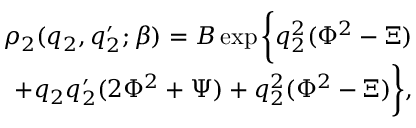Convert formula to latex. <formula><loc_0><loc_0><loc_500><loc_500>\begin{array} { r } { \rho _ { 2 } ( q _ { 2 } , q _ { 2 } ^ { \prime } ; \beta ) = B \exp \left \{ q _ { 2 } ^ { 2 } ( \Phi ^ { 2 } - \Xi ) } \\ { + q _ { 2 } q _ { 2 } ^ { \prime } ( 2 \Phi ^ { 2 } + \Psi ) + q _ { 2 } ^ { 2 } ( \Phi ^ { 2 } - \Xi ) \right \} , } \end{array}</formula> 